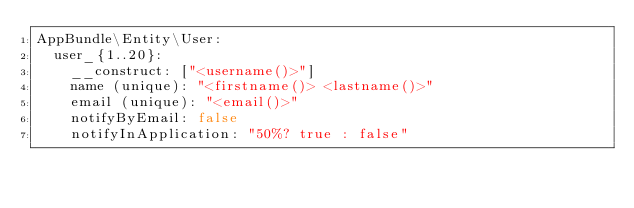Convert code to text. <code><loc_0><loc_0><loc_500><loc_500><_YAML_>AppBundle\Entity\User:
  user_{1..20}:
    __construct: ["<username()>"]
    name (unique): "<firstname()> <lastname()>"
    email (unique): "<email()>"
    notifyByEmail: false
    notifyInApplication: "50%? true : false"
</code> 